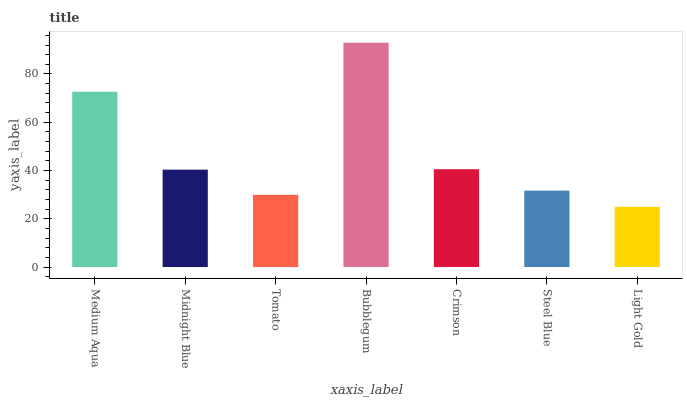Is Light Gold the minimum?
Answer yes or no. Yes. Is Bubblegum the maximum?
Answer yes or no. Yes. Is Midnight Blue the minimum?
Answer yes or no. No. Is Midnight Blue the maximum?
Answer yes or no. No. Is Medium Aqua greater than Midnight Blue?
Answer yes or no. Yes. Is Midnight Blue less than Medium Aqua?
Answer yes or no. Yes. Is Midnight Blue greater than Medium Aqua?
Answer yes or no. No. Is Medium Aqua less than Midnight Blue?
Answer yes or no. No. Is Midnight Blue the high median?
Answer yes or no. Yes. Is Midnight Blue the low median?
Answer yes or no. Yes. Is Steel Blue the high median?
Answer yes or no. No. Is Tomato the low median?
Answer yes or no. No. 